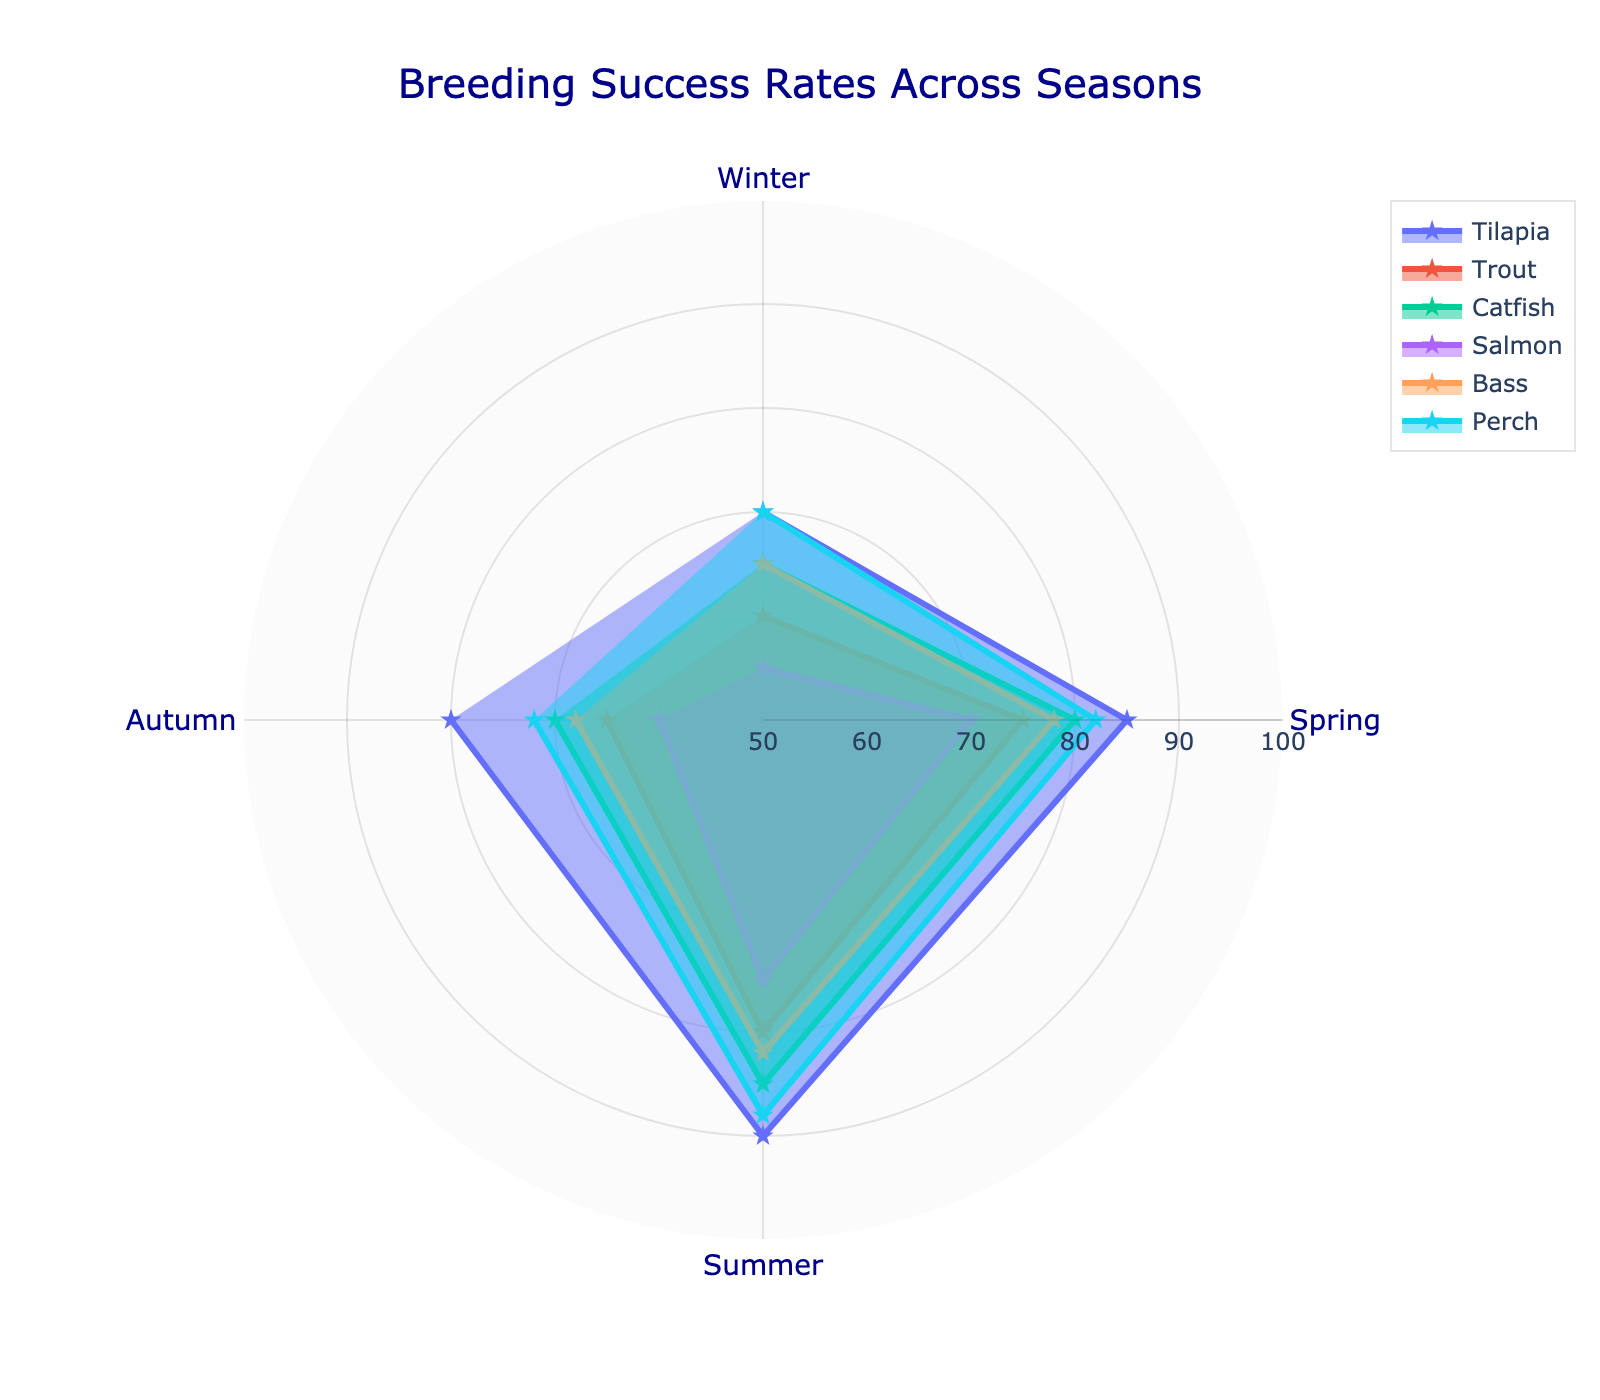What is the title of the radar chart? The title of the radar chart is located at the top of the figure. It provides an overview of what the chart represents.
Answer: Breeding Success Rates Across Seasons Which species has the highest breeding success rate in Summer? Look at the outermost point along the 'Summer' axis for each species.
Answer: Tilapia What's the average breeding success rate of Salmon across all seasons? Sum up the breeding success rates of Salmon in all four seasons and divide by the number of seasons: (55 + 70 + 75 + 60) / 4
Answer: 65 Which species show the least variation in breeding success rates across the seasons? Compare the range (difference between max and min values) of each species across all seasons. The species with the smallest range shows the least variation.
Answer: Perch During which season does Bass have the lowest breeding success rate? Identify the lowest point on the radar chart corresponding to Bass across all seasons.
Answer: Winter How does Trout's breeding success rate in Spring compare to its rate in Autumn? Compare the data points for Trout in Spring and Autumn. Specifically, look for the numerical values at these points on the radar chart.
Answer: Higher in Spring Which two species have the closest breeding success rates in Winter? Compare the Winter data points on the radar chart and identify the two species that have the closest values.
Answer: Tilapia and Perch What is the difference between Catfish's breeding success rates in Spring and Autumn? Subtract Catfish's breeding success rate in Autumn from its rate in Spring: 80 - 70
Answer: 10 During which season is the overall breeding success rate the highest for most species? Observe the overall data distribution along each seasonal axis and identify which season has the highest average values among the species.
Answer: Summer Rank all species based on their breeding success rate in Autumn from highest to lowest. List the breeding success rates of each species in Autumn and sort them in descending order.
Answer: Perch, Tilapia, Catfish, Bass, Trout, Salmon 